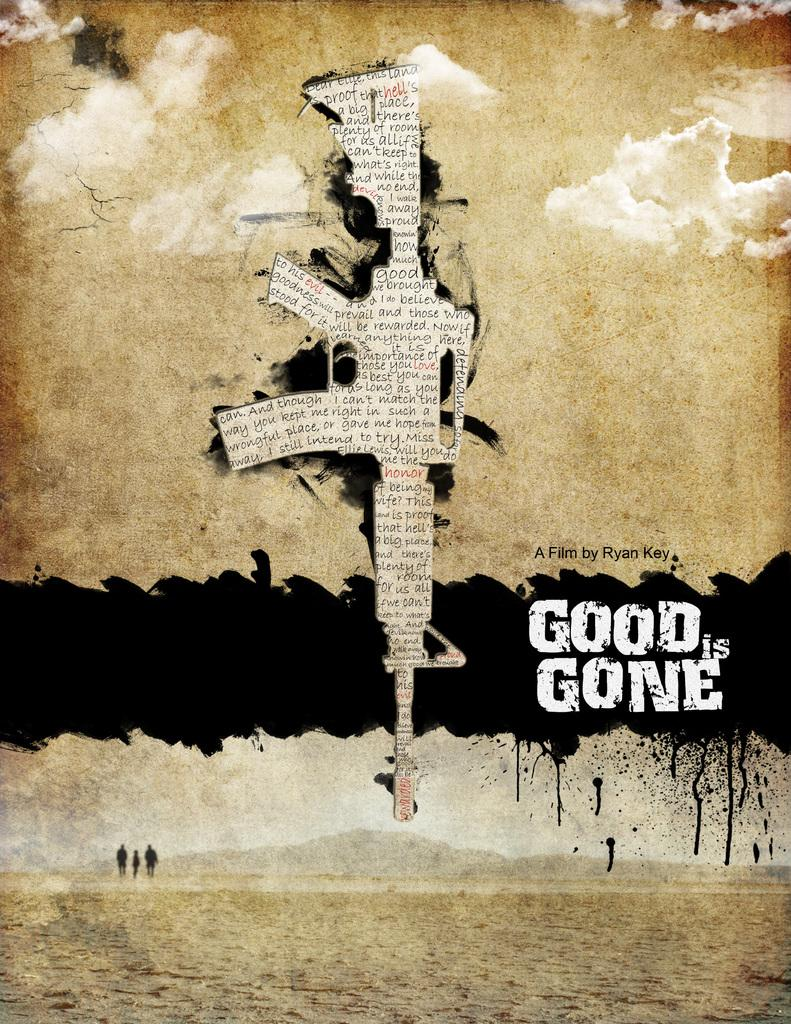<image>
Present a compact description of the photo's key features. The poster advertises a film that was made by Ryan Key. 